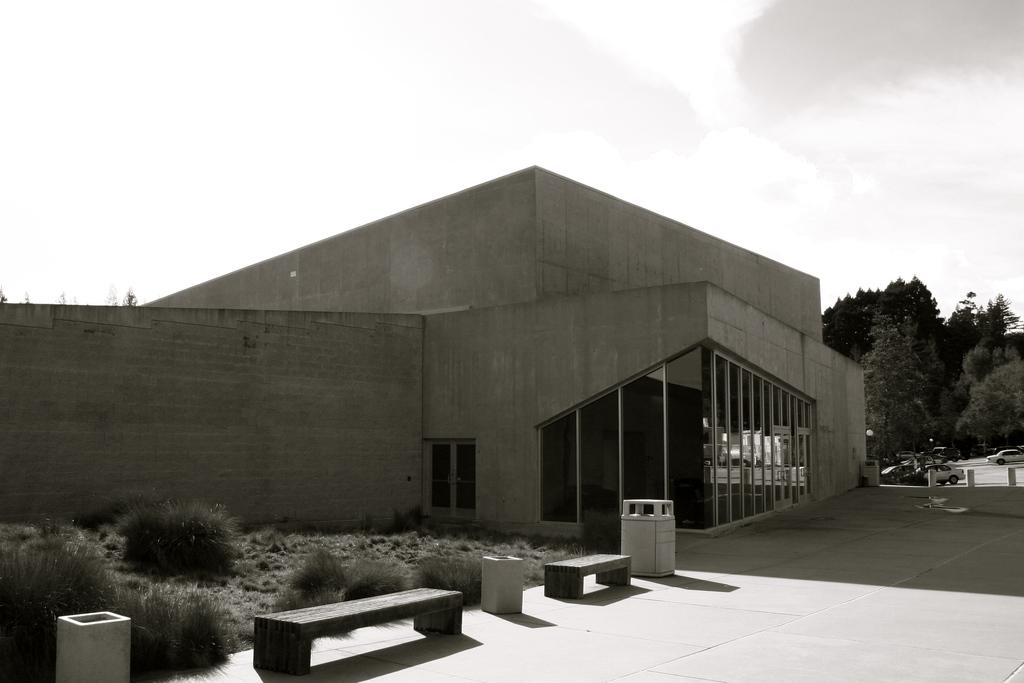What type of structure is present in the image? There is a building in the image. What features can be observed on the building? The building has a roof, windows, and a door. What additional objects are present in the image? There are plants, benches, a pole, trees, and cars on the road in the image. What can be seen in the background of the image? The sky is visible in the image, and it appears to be cloudy. What type of glass can be seen on the fang of the creature in the image? There is no creature or glass present in the image; it features a building, plants, benches, a pole, trees, cars, and a cloudy sky. 